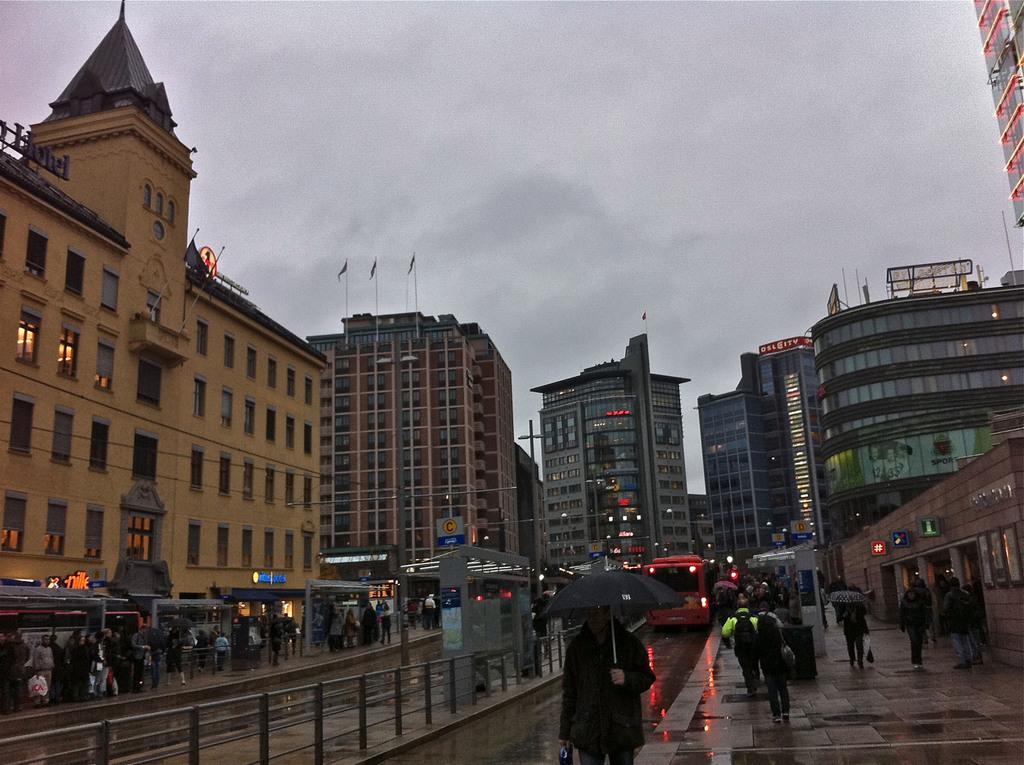Can you describe this image briefly? There is a road. On the road there are many people. A person is holding umbrella. In the back there is a vehicle. Also there is a railing. On the left side there are many people. There are small sheds. In the back there are many buildings with windows and lights. Also there are flags. And there is sky. 